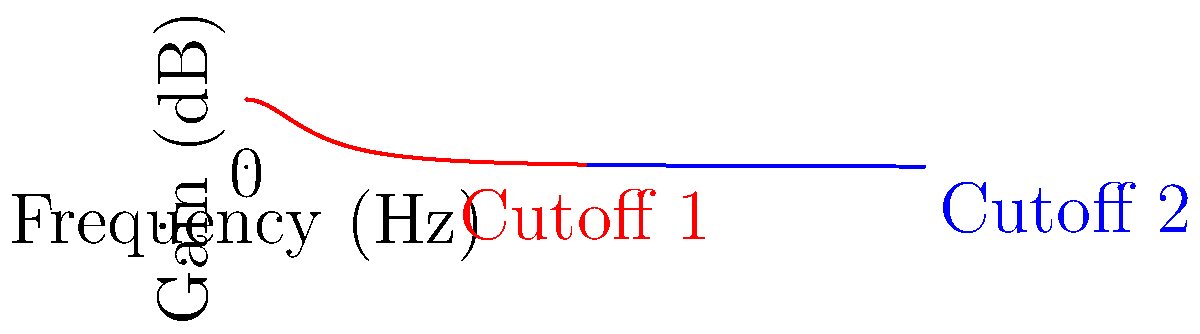In the graph above, two frequency response curves for a low-pass filter are shown. How does increasing the cutoff frequency affect the filter's response, and what implications does this have for audio signal processing? To understand the effect of increasing the cutoff frequency on a low-pass filter's response:

1. Observe the two curves: The red curve represents a lower cutoff frequency, while the blue curve represents a higher cutoff frequency.

2. Shape of the curves: Both curves start at 0 dB (maximum gain) for low frequencies and gradually decrease as frequency increases.

3. Cutoff point: The point where the gain drops by 3 dB is considered the cutoff frequency. The blue curve's cutoff point occurs at a higher frequency than the red curve's.

4. Passband: The frequency range below the cutoff point is called the passband. The blue curve has a wider passband, allowing more high-frequency content to pass through.

5. Rolloff: After the cutoff point, both curves show a rolloff, where higher frequencies are increasingly attenuated.

6. Effect on audio: Increasing the cutoff frequency (blue curve) allows more high-frequency content to pass through the filter, resulting in a brighter sound with more treble.

7. Applications: Adjustable cutoff frequencies in low-pass filters are useful for:
   a) Removing unwanted high-frequency noise
   b) Shaping the tonal character of sounds
   c) Creating filter sweeps for electronic music effects

8. Implementation: In plugin development, this adjustable cutoff can be controlled by a user interface element like a knob or slider, allowing real-time manipulation of the filter's response.
Answer: Increasing the cutoff frequency widens the passband, allowing more high-frequency content to pass through, resulting in a brighter sound with more treble presence. 